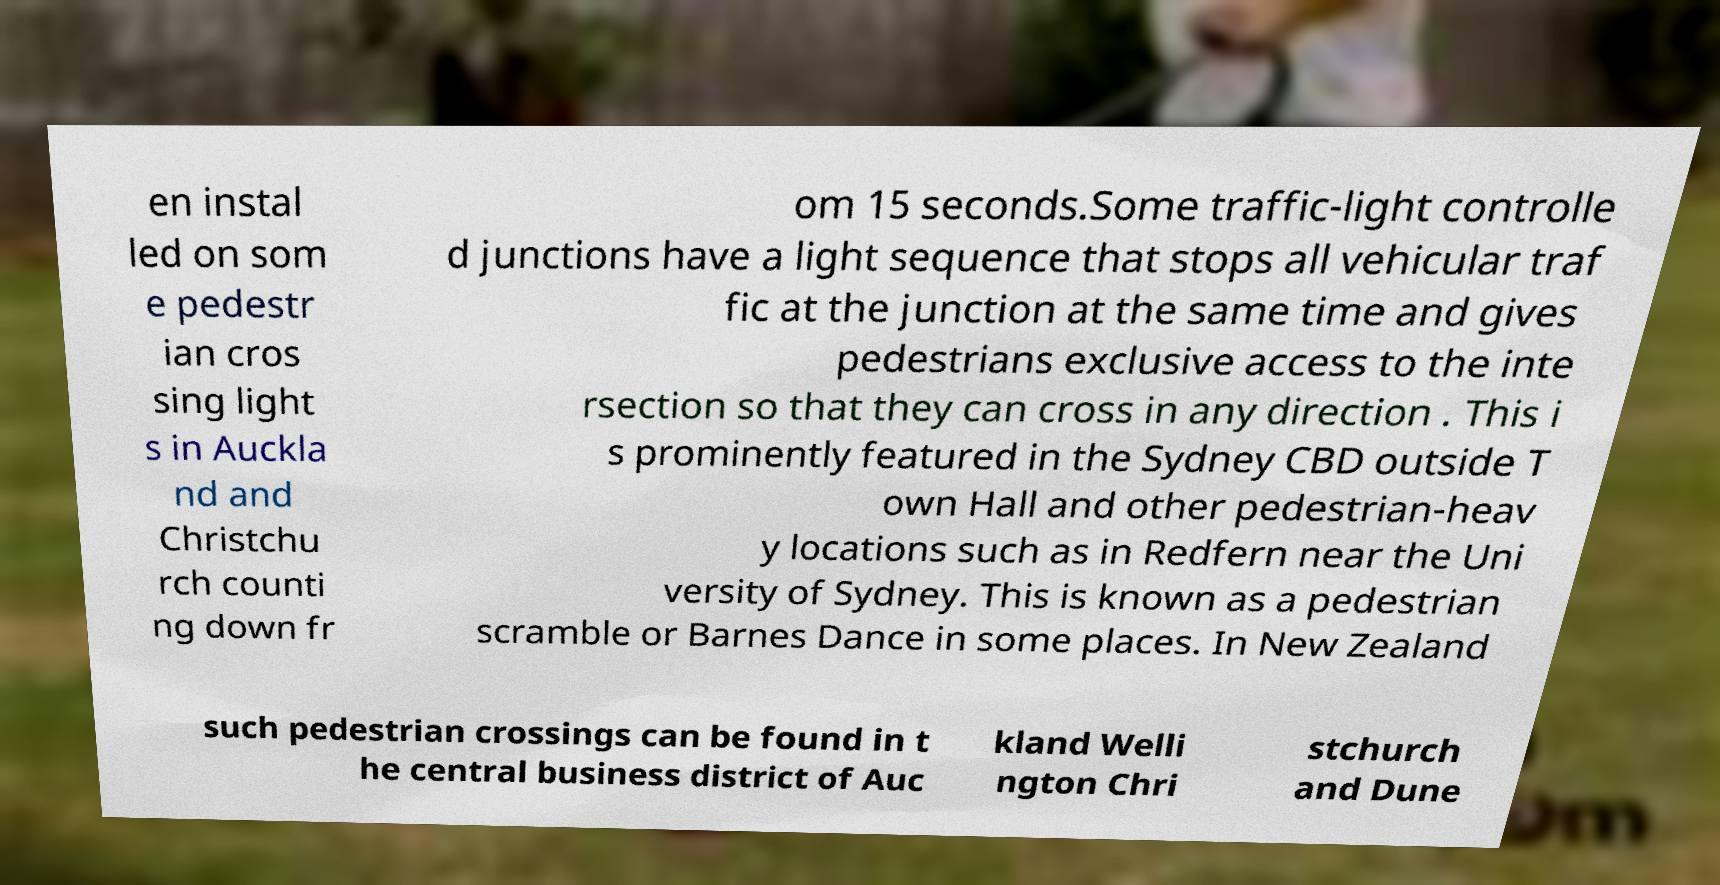I need the written content from this picture converted into text. Can you do that? en instal led on som e pedestr ian cros sing light s in Auckla nd and Christchu rch counti ng down fr om 15 seconds.Some traffic-light controlle d junctions have a light sequence that stops all vehicular traf fic at the junction at the same time and gives pedestrians exclusive access to the inte rsection so that they can cross in any direction . This i s prominently featured in the Sydney CBD outside T own Hall and other pedestrian-heav y locations such as in Redfern near the Uni versity of Sydney. This is known as a pedestrian scramble or Barnes Dance in some places. In New Zealand such pedestrian crossings can be found in t he central business district of Auc kland Welli ngton Chri stchurch and Dune 